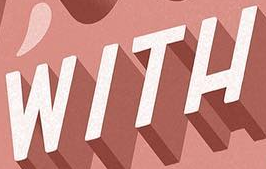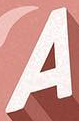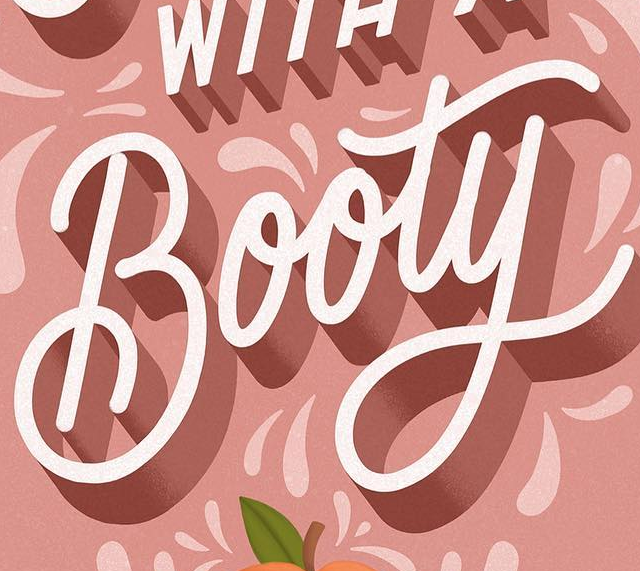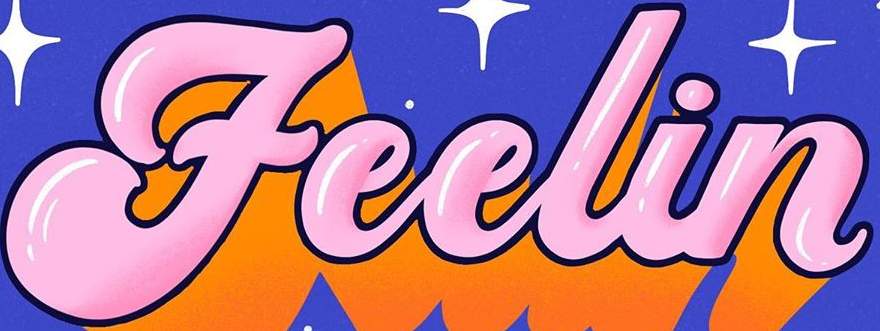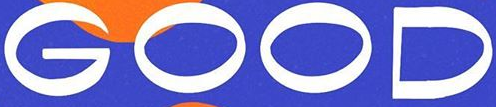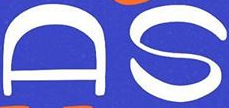Identify the words shown in these images in order, separated by a semicolon. WITH; A; Booty; Feelin; GOOD; AS 